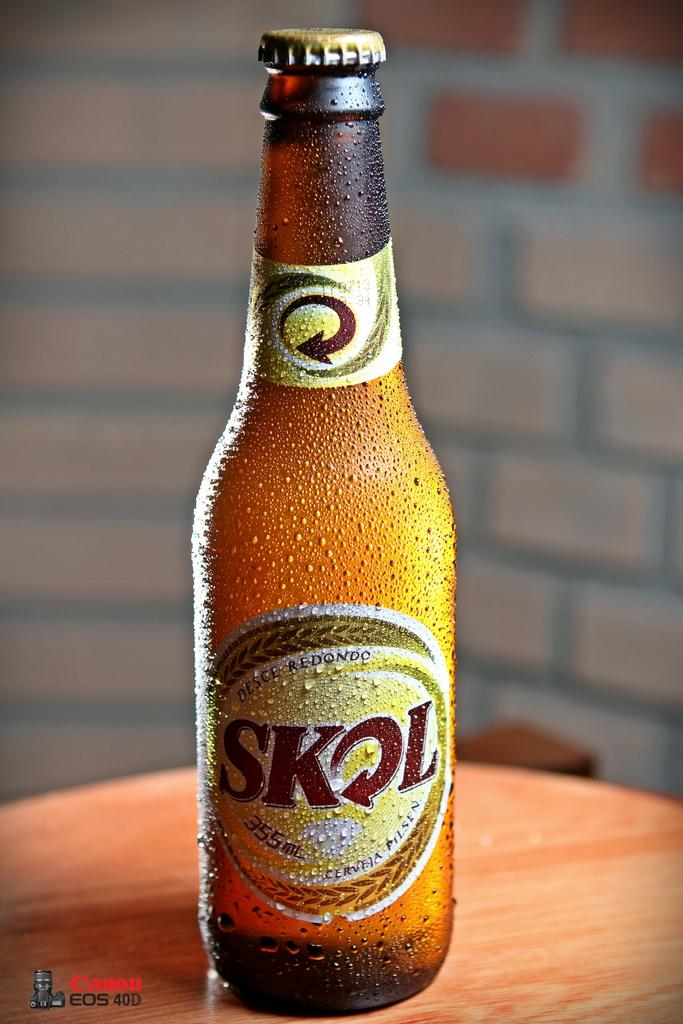Provide a one-sentence caption for the provided image. A bottle of Skol looks frosty cold and is covered with moisture condensation. 